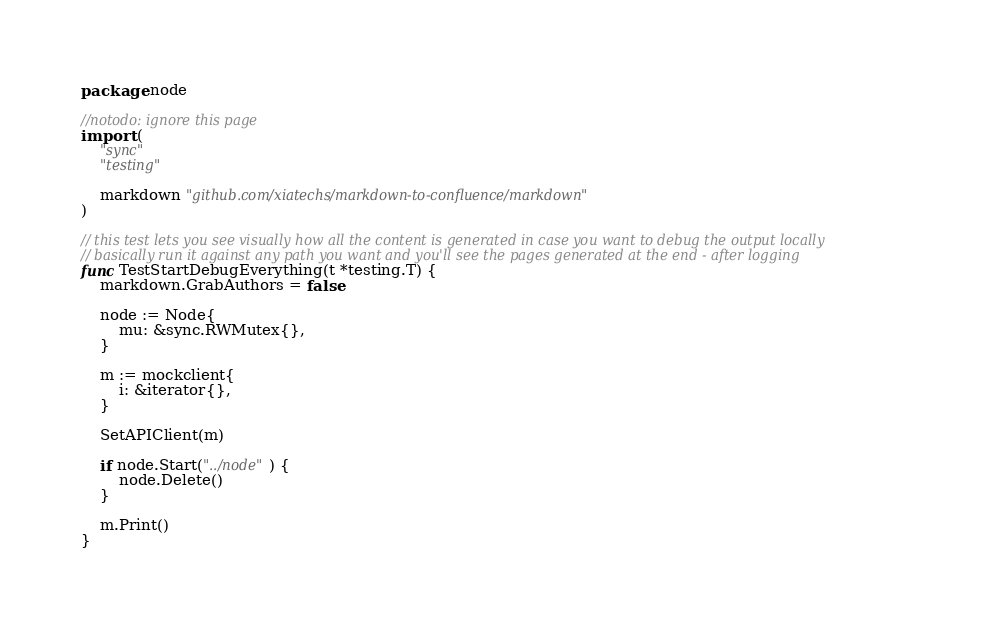<code> <loc_0><loc_0><loc_500><loc_500><_Go_>package node

//notodo: ignore this page
import (
	"sync"
	"testing"

	markdown "github.com/xiatechs/markdown-to-confluence/markdown"
)

// this test lets you see visually how all the content is generated in case you want to debug the output locally
// basically run it against any path you want and you'll see the pages generated at the end - after logging
func TestStartDebugEverything(t *testing.T) {
	markdown.GrabAuthors = false

	node := Node{
		mu: &sync.RWMutex{},
	}

	m := mockclient{
		i: &iterator{},
	}

	SetAPIClient(m)

	if node.Start("../node") {
		node.Delete()
	}

	m.Print()
}
</code> 